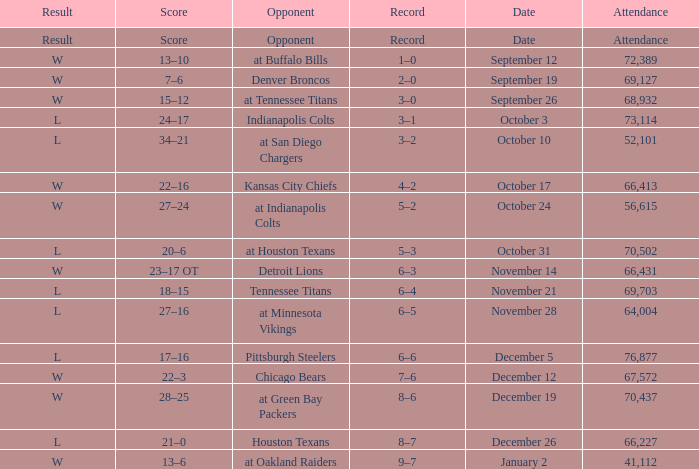What score has houston texans as the opponent? 21–0. 